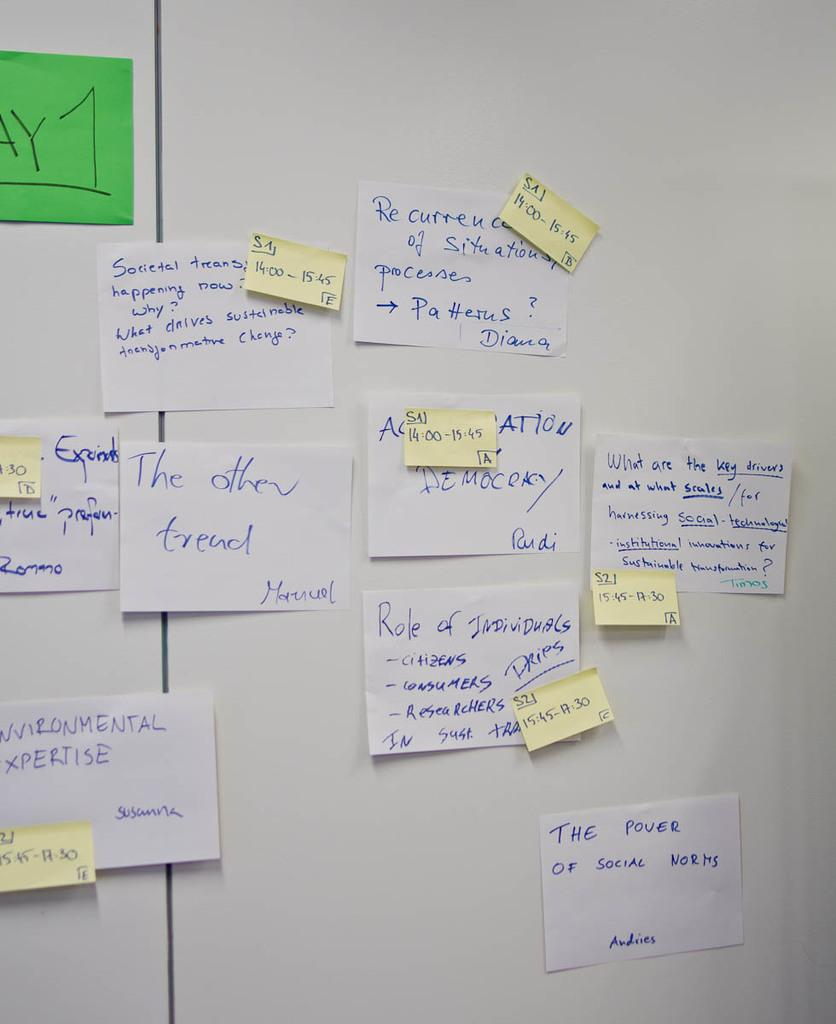<image>
Summarize the visual content of the image. White background littered with "Day 1" sticky notes which seem to act as guidelines for workers. 